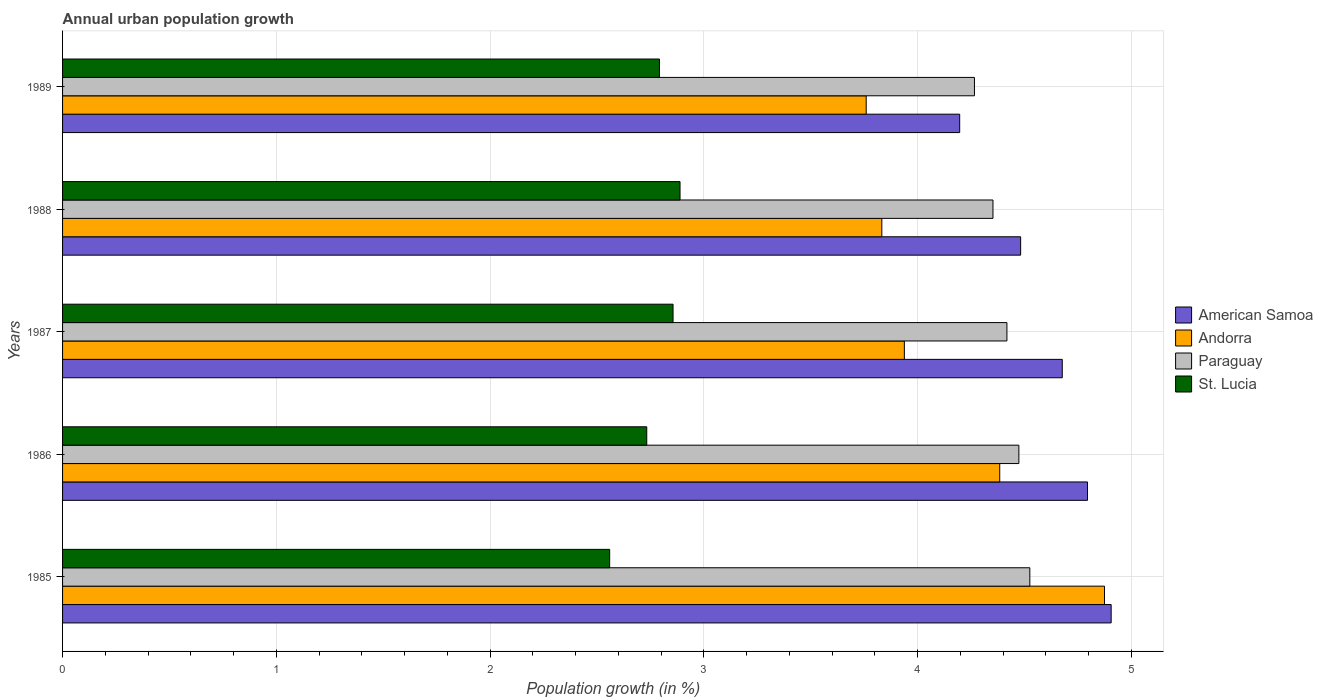Are the number of bars on each tick of the Y-axis equal?
Make the answer very short. Yes. How many bars are there on the 2nd tick from the top?
Give a very brief answer. 4. How many bars are there on the 1st tick from the bottom?
Offer a very short reply. 4. What is the label of the 3rd group of bars from the top?
Provide a succinct answer. 1987. What is the percentage of urban population growth in American Samoa in 1985?
Provide a succinct answer. 4.91. Across all years, what is the maximum percentage of urban population growth in Andorra?
Your answer should be compact. 4.87. Across all years, what is the minimum percentage of urban population growth in American Samoa?
Keep it short and to the point. 4.2. In which year was the percentage of urban population growth in Paraguay maximum?
Your response must be concise. 1985. What is the total percentage of urban population growth in Paraguay in the graph?
Your response must be concise. 22.04. What is the difference between the percentage of urban population growth in American Samoa in 1985 and that in 1987?
Provide a succinct answer. 0.23. What is the difference between the percentage of urban population growth in St. Lucia in 1989 and the percentage of urban population growth in American Samoa in 1986?
Offer a very short reply. -2. What is the average percentage of urban population growth in Andorra per year?
Provide a succinct answer. 4.16. In the year 1988, what is the difference between the percentage of urban population growth in Andorra and percentage of urban population growth in American Samoa?
Your response must be concise. -0.65. In how many years, is the percentage of urban population growth in Andorra greater than 0.6000000000000001 %?
Your answer should be very brief. 5. What is the ratio of the percentage of urban population growth in Andorra in 1986 to that in 1987?
Your answer should be compact. 1.11. Is the percentage of urban population growth in St. Lucia in 1985 less than that in 1989?
Provide a short and direct response. Yes. Is the difference between the percentage of urban population growth in Andorra in 1986 and 1987 greater than the difference between the percentage of urban population growth in American Samoa in 1986 and 1987?
Provide a short and direct response. Yes. What is the difference between the highest and the second highest percentage of urban population growth in St. Lucia?
Your answer should be compact. 0.03. What is the difference between the highest and the lowest percentage of urban population growth in American Samoa?
Ensure brevity in your answer.  0.71. In how many years, is the percentage of urban population growth in American Samoa greater than the average percentage of urban population growth in American Samoa taken over all years?
Ensure brevity in your answer.  3. Is it the case that in every year, the sum of the percentage of urban population growth in Andorra and percentage of urban population growth in Paraguay is greater than the sum of percentage of urban population growth in American Samoa and percentage of urban population growth in St. Lucia?
Provide a succinct answer. No. What does the 4th bar from the top in 1988 represents?
Ensure brevity in your answer.  American Samoa. What does the 2nd bar from the bottom in 1988 represents?
Offer a terse response. Andorra. Is it the case that in every year, the sum of the percentage of urban population growth in St. Lucia and percentage of urban population growth in Paraguay is greater than the percentage of urban population growth in American Samoa?
Your answer should be very brief. Yes. How many bars are there?
Your answer should be compact. 20. What is the difference between two consecutive major ticks on the X-axis?
Provide a short and direct response. 1. Does the graph contain grids?
Ensure brevity in your answer.  Yes. Where does the legend appear in the graph?
Your response must be concise. Center right. How are the legend labels stacked?
Give a very brief answer. Vertical. What is the title of the graph?
Offer a terse response. Annual urban population growth. What is the label or title of the X-axis?
Give a very brief answer. Population growth (in %). What is the label or title of the Y-axis?
Your answer should be compact. Years. What is the Population growth (in %) of American Samoa in 1985?
Make the answer very short. 4.91. What is the Population growth (in %) of Andorra in 1985?
Provide a succinct answer. 4.87. What is the Population growth (in %) in Paraguay in 1985?
Provide a succinct answer. 4.53. What is the Population growth (in %) in St. Lucia in 1985?
Make the answer very short. 2.56. What is the Population growth (in %) of American Samoa in 1986?
Offer a very short reply. 4.79. What is the Population growth (in %) in Andorra in 1986?
Offer a very short reply. 4.38. What is the Population growth (in %) of Paraguay in 1986?
Provide a short and direct response. 4.47. What is the Population growth (in %) of St. Lucia in 1986?
Provide a short and direct response. 2.73. What is the Population growth (in %) in American Samoa in 1987?
Keep it short and to the point. 4.68. What is the Population growth (in %) of Andorra in 1987?
Give a very brief answer. 3.94. What is the Population growth (in %) in Paraguay in 1987?
Your answer should be very brief. 4.42. What is the Population growth (in %) in St. Lucia in 1987?
Provide a short and direct response. 2.86. What is the Population growth (in %) in American Samoa in 1988?
Provide a short and direct response. 4.48. What is the Population growth (in %) of Andorra in 1988?
Keep it short and to the point. 3.83. What is the Population growth (in %) in Paraguay in 1988?
Keep it short and to the point. 4.35. What is the Population growth (in %) of St. Lucia in 1988?
Ensure brevity in your answer.  2.89. What is the Population growth (in %) in American Samoa in 1989?
Your answer should be compact. 4.2. What is the Population growth (in %) of Andorra in 1989?
Your answer should be very brief. 3.76. What is the Population growth (in %) of Paraguay in 1989?
Your answer should be very brief. 4.27. What is the Population growth (in %) in St. Lucia in 1989?
Offer a very short reply. 2.79. Across all years, what is the maximum Population growth (in %) of American Samoa?
Your answer should be compact. 4.91. Across all years, what is the maximum Population growth (in %) of Andorra?
Your response must be concise. 4.87. Across all years, what is the maximum Population growth (in %) in Paraguay?
Provide a succinct answer. 4.53. Across all years, what is the maximum Population growth (in %) in St. Lucia?
Offer a terse response. 2.89. Across all years, what is the minimum Population growth (in %) in American Samoa?
Offer a terse response. 4.2. Across all years, what is the minimum Population growth (in %) in Andorra?
Your response must be concise. 3.76. Across all years, what is the minimum Population growth (in %) of Paraguay?
Give a very brief answer. 4.27. Across all years, what is the minimum Population growth (in %) in St. Lucia?
Offer a very short reply. 2.56. What is the total Population growth (in %) in American Samoa in the graph?
Provide a succinct answer. 23.06. What is the total Population growth (in %) of Andorra in the graph?
Provide a succinct answer. 20.79. What is the total Population growth (in %) in Paraguay in the graph?
Ensure brevity in your answer.  22.04. What is the total Population growth (in %) of St. Lucia in the graph?
Provide a succinct answer. 13.83. What is the difference between the Population growth (in %) in American Samoa in 1985 and that in 1986?
Your response must be concise. 0.11. What is the difference between the Population growth (in %) in Andorra in 1985 and that in 1986?
Your answer should be very brief. 0.49. What is the difference between the Population growth (in %) in Paraguay in 1985 and that in 1986?
Offer a very short reply. 0.05. What is the difference between the Population growth (in %) in St. Lucia in 1985 and that in 1986?
Ensure brevity in your answer.  -0.17. What is the difference between the Population growth (in %) in American Samoa in 1985 and that in 1987?
Your answer should be compact. 0.23. What is the difference between the Population growth (in %) of Andorra in 1985 and that in 1987?
Keep it short and to the point. 0.94. What is the difference between the Population growth (in %) of Paraguay in 1985 and that in 1987?
Provide a short and direct response. 0.11. What is the difference between the Population growth (in %) of St. Lucia in 1985 and that in 1987?
Your answer should be very brief. -0.3. What is the difference between the Population growth (in %) of American Samoa in 1985 and that in 1988?
Offer a terse response. 0.42. What is the difference between the Population growth (in %) in Andorra in 1985 and that in 1988?
Offer a terse response. 1.04. What is the difference between the Population growth (in %) in Paraguay in 1985 and that in 1988?
Your response must be concise. 0.17. What is the difference between the Population growth (in %) in St. Lucia in 1985 and that in 1988?
Keep it short and to the point. -0.33. What is the difference between the Population growth (in %) of American Samoa in 1985 and that in 1989?
Make the answer very short. 0.71. What is the difference between the Population growth (in %) in Andorra in 1985 and that in 1989?
Provide a short and direct response. 1.11. What is the difference between the Population growth (in %) in Paraguay in 1985 and that in 1989?
Offer a terse response. 0.26. What is the difference between the Population growth (in %) in St. Lucia in 1985 and that in 1989?
Your answer should be compact. -0.23. What is the difference between the Population growth (in %) of American Samoa in 1986 and that in 1987?
Provide a succinct answer. 0.12. What is the difference between the Population growth (in %) in Andorra in 1986 and that in 1987?
Keep it short and to the point. 0.45. What is the difference between the Population growth (in %) in Paraguay in 1986 and that in 1987?
Ensure brevity in your answer.  0.06. What is the difference between the Population growth (in %) in St. Lucia in 1986 and that in 1987?
Keep it short and to the point. -0.12. What is the difference between the Population growth (in %) of American Samoa in 1986 and that in 1988?
Offer a terse response. 0.31. What is the difference between the Population growth (in %) in Andorra in 1986 and that in 1988?
Provide a succinct answer. 0.55. What is the difference between the Population growth (in %) of Paraguay in 1986 and that in 1988?
Offer a terse response. 0.12. What is the difference between the Population growth (in %) in St. Lucia in 1986 and that in 1988?
Your answer should be very brief. -0.16. What is the difference between the Population growth (in %) in American Samoa in 1986 and that in 1989?
Your answer should be very brief. 0.6. What is the difference between the Population growth (in %) of Andorra in 1986 and that in 1989?
Offer a very short reply. 0.62. What is the difference between the Population growth (in %) in Paraguay in 1986 and that in 1989?
Your answer should be very brief. 0.21. What is the difference between the Population growth (in %) of St. Lucia in 1986 and that in 1989?
Provide a succinct answer. -0.06. What is the difference between the Population growth (in %) of American Samoa in 1987 and that in 1988?
Offer a very short reply. 0.19. What is the difference between the Population growth (in %) of Andorra in 1987 and that in 1988?
Offer a very short reply. 0.11. What is the difference between the Population growth (in %) in Paraguay in 1987 and that in 1988?
Provide a succinct answer. 0.07. What is the difference between the Population growth (in %) in St. Lucia in 1987 and that in 1988?
Provide a short and direct response. -0.03. What is the difference between the Population growth (in %) in American Samoa in 1987 and that in 1989?
Make the answer very short. 0.48. What is the difference between the Population growth (in %) in Andorra in 1987 and that in 1989?
Offer a very short reply. 0.18. What is the difference between the Population growth (in %) of Paraguay in 1987 and that in 1989?
Your response must be concise. 0.15. What is the difference between the Population growth (in %) of St. Lucia in 1987 and that in 1989?
Offer a terse response. 0.06. What is the difference between the Population growth (in %) in American Samoa in 1988 and that in 1989?
Provide a succinct answer. 0.29. What is the difference between the Population growth (in %) in Andorra in 1988 and that in 1989?
Keep it short and to the point. 0.07. What is the difference between the Population growth (in %) in Paraguay in 1988 and that in 1989?
Keep it short and to the point. 0.09. What is the difference between the Population growth (in %) of St. Lucia in 1988 and that in 1989?
Keep it short and to the point. 0.1. What is the difference between the Population growth (in %) in American Samoa in 1985 and the Population growth (in %) in Andorra in 1986?
Keep it short and to the point. 0.52. What is the difference between the Population growth (in %) of American Samoa in 1985 and the Population growth (in %) of Paraguay in 1986?
Your response must be concise. 0.43. What is the difference between the Population growth (in %) of American Samoa in 1985 and the Population growth (in %) of St. Lucia in 1986?
Ensure brevity in your answer.  2.17. What is the difference between the Population growth (in %) of Andorra in 1985 and the Population growth (in %) of Paraguay in 1986?
Give a very brief answer. 0.4. What is the difference between the Population growth (in %) of Andorra in 1985 and the Population growth (in %) of St. Lucia in 1986?
Give a very brief answer. 2.14. What is the difference between the Population growth (in %) of Paraguay in 1985 and the Population growth (in %) of St. Lucia in 1986?
Provide a short and direct response. 1.79. What is the difference between the Population growth (in %) of American Samoa in 1985 and the Population growth (in %) of Andorra in 1987?
Your answer should be very brief. 0.97. What is the difference between the Population growth (in %) of American Samoa in 1985 and the Population growth (in %) of Paraguay in 1987?
Give a very brief answer. 0.49. What is the difference between the Population growth (in %) of American Samoa in 1985 and the Population growth (in %) of St. Lucia in 1987?
Your answer should be very brief. 2.05. What is the difference between the Population growth (in %) in Andorra in 1985 and the Population growth (in %) in Paraguay in 1987?
Offer a very short reply. 0.46. What is the difference between the Population growth (in %) in Andorra in 1985 and the Population growth (in %) in St. Lucia in 1987?
Give a very brief answer. 2.02. What is the difference between the Population growth (in %) in Paraguay in 1985 and the Population growth (in %) in St. Lucia in 1987?
Provide a short and direct response. 1.67. What is the difference between the Population growth (in %) of American Samoa in 1985 and the Population growth (in %) of Andorra in 1988?
Your answer should be compact. 1.07. What is the difference between the Population growth (in %) in American Samoa in 1985 and the Population growth (in %) in Paraguay in 1988?
Provide a short and direct response. 0.55. What is the difference between the Population growth (in %) of American Samoa in 1985 and the Population growth (in %) of St. Lucia in 1988?
Make the answer very short. 2.02. What is the difference between the Population growth (in %) in Andorra in 1985 and the Population growth (in %) in Paraguay in 1988?
Provide a succinct answer. 0.52. What is the difference between the Population growth (in %) of Andorra in 1985 and the Population growth (in %) of St. Lucia in 1988?
Your answer should be very brief. 1.99. What is the difference between the Population growth (in %) of Paraguay in 1985 and the Population growth (in %) of St. Lucia in 1988?
Ensure brevity in your answer.  1.64. What is the difference between the Population growth (in %) in American Samoa in 1985 and the Population growth (in %) in Andorra in 1989?
Offer a very short reply. 1.15. What is the difference between the Population growth (in %) in American Samoa in 1985 and the Population growth (in %) in Paraguay in 1989?
Provide a short and direct response. 0.64. What is the difference between the Population growth (in %) in American Samoa in 1985 and the Population growth (in %) in St. Lucia in 1989?
Your response must be concise. 2.11. What is the difference between the Population growth (in %) of Andorra in 1985 and the Population growth (in %) of Paraguay in 1989?
Give a very brief answer. 0.61. What is the difference between the Population growth (in %) of Andorra in 1985 and the Population growth (in %) of St. Lucia in 1989?
Your answer should be compact. 2.08. What is the difference between the Population growth (in %) of Paraguay in 1985 and the Population growth (in %) of St. Lucia in 1989?
Your answer should be compact. 1.73. What is the difference between the Population growth (in %) of American Samoa in 1986 and the Population growth (in %) of Andorra in 1987?
Make the answer very short. 0.86. What is the difference between the Population growth (in %) of American Samoa in 1986 and the Population growth (in %) of Paraguay in 1987?
Offer a terse response. 0.38. What is the difference between the Population growth (in %) in American Samoa in 1986 and the Population growth (in %) in St. Lucia in 1987?
Offer a terse response. 1.94. What is the difference between the Population growth (in %) of Andorra in 1986 and the Population growth (in %) of Paraguay in 1987?
Give a very brief answer. -0.03. What is the difference between the Population growth (in %) of Andorra in 1986 and the Population growth (in %) of St. Lucia in 1987?
Your answer should be very brief. 1.53. What is the difference between the Population growth (in %) in Paraguay in 1986 and the Population growth (in %) in St. Lucia in 1987?
Give a very brief answer. 1.62. What is the difference between the Population growth (in %) of American Samoa in 1986 and the Population growth (in %) of Andorra in 1988?
Your response must be concise. 0.96. What is the difference between the Population growth (in %) in American Samoa in 1986 and the Population growth (in %) in Paraguay in 1988?
Give a very brief answer. 0.44. What is the difference between the Population growth (in %) in American Samoa in 1986 and the Population growth (in %) in St. Lucia in 1988?
Provide a succinct answer. 1.91. What is the difference between the Population growth (in %) of Andorra in 1986 and the Population growth (in %) of Paraguay in 1988?
Your response must be concise. 0.03. What is the difference between the Population growth (in %) of Andorra in 1986 and the Population growth (in %) of St. Lucia in 1988?
Make the answer very short. 1.5. What is the difference between the Population growth (in %) of Paraguay in 1986 and the Population growth (in %) of St. Lucia in 1988?
Your answer should be compact. 1.59. What is the difference between the Population growth (in %) of American Samoa in 1986 and the Population growth (in %) of Andorra in 1989?
Provide a short and direct response. 1.04. What is the difference between the Population growth (in %) of American Samoa in 1986 and the Population growth (in %) of Paraguay in 1989?
Provide a succinct answer. 0.53. What is the difference between the Population growth (in %) in American Samoa in 1986 and the Population growth (in %) in St. Lucia in 1989?
Offer a terse response. 2. What is the difference between the Population growth (in %) in Andorra in 1986 and the Population growth (in %) in Paraguay in 1989?
Your answer should be compact. 0.12. What is the difference between the Population growth (in %) of Andorra in 1986 and the Population growth (in %) of St. Lucia in 1989?
Your answer should be very brief. 1.59. What is the difference between the Population growth (in %) in Paraguay in 1986 and the Population growth (in %) in St. Lucia in 1989?
Provide a succinct answer. 1.68. What is the difference between the Population growth (in %) of American Samoa in 1987 and the Population growth (in %) of Andorra in 1988?
Offer a terse response. 0.84. What is the difference between the Population growth (in %) in American Samoa in 1987 and the Population growth (in %) in Paraguay in 1988?
Give a very brief answer. 0.32. What is the difference between the Population growth (in %) of American Samoa in 1987 and the Population growth (in %) of St. Lucia in 1988?
Provide a succinct answer. 1.79. What is the difference between the Population growth (in %) in Andorra in 1987 and the Population growth (in %) in Paraguay in 1988?
Provide a succinct answer. -0.41. What is the difference between the Population growth (in %) in Andorra in 1987 and the Population growth (in %) in St. Lucia in 1988?
Provide a succinct answer. 1.05. What is the difference between the Population growth (in %) in Paraguay in 1987 and the Population growth (in %) in St. Lucia in 1988?
Keep it short and to the point. 1.53. What is the difference between the Population growth (in %) in American Samoa in 1987 and the Population growth (in %) in Andorra in 1989?
Keep it short and to the point. 0.92. What is the difference between the Population growth (in %) in American Samoa in 1987 and the Population growth (in %) in Paraguay in 1989?
Keep it short and to the point. 0.41. What is the difference between the Population growth (in %) in American Samoa in 1987 and the Population growth (in %) in St. Lucia in 1989?
Give a very brief answer. 1.88. What is the difference between the Population growth (in %) of Andorra in 1987 and the Population growth (in %) of Paraguay in 1989?
Offer a terse response. -0.33. What is the difference between the Population growth (in %) in Andorra in 1987 and the Population growth (in %) in St. Lucia in 1989?
Offer a terse response. 1.15. What is the difference between the Population growth (in %) in Paraguay in 1987 and the Population growth (in %) in St. Lucia in 1989?
Give a very brief answer. 1.63. What is the difference between the Population growth (in %) of American Samoa in 1988 and the Population growth (in %) of Andorra in 1989?
Offer a very short reply. 0.72. What is the difference between the Population growth (in %) of American Samoa in 1988 and the Population growth (in %) of Paraguay in 1989?
Your answer should be very brief. 0.22. What is the difference between the Population growth (in %) in American Samoa in 1988 and the Population growth (in %) in St. Lucia in 1989?
Your answer should be very brief. 1.69. What is the difference between the Population growth (in %) in Andorra in 1988 and the Population growth (in %) in Paraguay in 1989?
Give a very brief answer. -0.43. What is the difference between the Population growth (in %) in Andorra in 1988 and the Population growth (in %) in St. Lucia in 1989?
Provide a succinct answer. 1.04. What is the difference between the Population growth (in %) of Paraguay in 1988 and the Population growth (in %) of St. Lucia in 1989?
Your answer should be compact. 1.56. What is the average Population growth (in %) of American Samoa per year?
Make the answer very short. 4.61. What is the average Population growth (in %) of Andorra per year?
Your response must be concise. 4.16. What is the average Population growth (in %) in Paraguay per year?
Provide a short and direct response. 4.41. What is the average Population growth (in %) in St. Lucia per year?
Your response must be concise. 2.77. In the year 1985, what is the difference between the Population growth (in %) in American Samoa and Population growth (in %) in Andorra?
Give a very brief answer. 0.03. In the year 1985, what is the difference between the Population growth (in %) in American Samoa and Population growth (in %) in Paraguay?
Give a very brief answer. 0.38. In the year 1985, what is the difference between the Population growth (in %) in American Samoa and Population growth (in %) in St. Lucia?
Give a very brief answer. 2.35. In the year 1985, what is the difference between the Population growth (in %) in Andorra and Population growth (in %) in Paraguay?
Ensure brevity in your answer.  0.35. In the year 1985, what is the difference between the Population growth (in %) in Andorra and Population growth (in %) in St. Lucia?
Give a very brief answer. 2.31. In the year 1985, what is the difference between the Population growth (in %) of Paraguay and Population growth (in %) of St. Lucia?
Provide a succinct answer. 1.97. In the year 1986, what is the difference between the Population growth (in %) in American Samoa and Population growth (in %) in Andorra?
Make the answer very short. 0.41. In the year 1986, what is the difference between the Population growth (in %) of American Samoa and Population growth (in %) of Paraguay?
Make the answer very short. 0.32. In the year 1986, what is the difference between the Population growth (in %) of American Samoa and Population growth (in %) of St. Lucia?
Provide a succinct answer. 2.06. In the year 1986, what is the difference between the Population growth (in %) in Andorra and Population growth (in %) in Paraguay?
Your answer should be compact. -0.09. In the year 1986, what is the difference between the Population growth (in %) of Andorra and Population growth (in %) of St. Lucia?
Make the answer very short. 1.65. In the year 1986, what is the difference between the Population growth (in %) in Paraguay and Population growth (in %) in St. Lucia?
Offer a terse response. 1.74. In the year 1987, what is the difference between the Population growth (in %) in American Samoa and Population growth (in %) in Andorra?
Keep it short and to the point. 0.74. In the year 1987, what is the difference between the Population growth (in %) in American Samoa and Population growth (in %) in Paraguay?
Offer a very short reply. 0.26. In the year 1987, what is the difference between the Population growth (in %) of American Samoa and Population growth (in %) of St. Lucia?
Your answer should be compact. 1.82. In the year 1987, what is the difference between the Population growth (in %) of Andorra and Population growth (in %) of Paraguay?
Provide a succinct answer. -0.48. In the year 1987, what is the difference between the Population growth (in %) of Andorra and Population growth (in %) of St. Lucia?
Your answer should be compact. 1.08. In the year 1987, what is the difference between the Population growth (in %) in Paraguay and Population growth (in %) in St. Lucia?
Offer a very short reply. 1.56. In the year 1988, what is the difference between the Population growth (in %) of American Samoa and Population growth (in %) of Andorra?
Offer a terse response. 0.65. In the year 1988, what is the difference between the Population growth (in %) of American Samoa and Population growth (in %) of Paraguay?
Offer a terse response. 0.13. In the year 1988, what is the difference between the Population growth (in %) of American Samoa and Population growth (in %) of St. Lucia?
Your response must be concise. 1.59. In the year 1988, what is the difference between the Population growth (in %) of Andorra and Population growth (in %) of Paraguay?
Your answer should be very brief. -0.52. In the year 1988, what is the difference between the Population growth (in %) of Andorra and Population growth (in %) of St. Lucia?
Provide a short and direct response. 0.94. In the year 1988, what is the difference between the Population growth (in %) of Paraguay and Population growth (in %) of St. Lucia?
Ensure brevity in your answer.  1.46. In the year 1989, what is the difference between the Population growth (in %) of American Samoa and Population growth (in %) of Andorra?
Make the answer very short. 0.44. In the year 1989, what is the difference between the Population growth (in %) of American Samoa and Population growth (in %) of Paraguay?
Offer a very short reply. -0.07. In the year 1989, what is the difference between the Population growth (in %) of American Samoa and Population growth (in %) of St. Lucia?
Make the answer very short. 1.4. In the year 1989, what is the difference between the Population growth (in %) in Andorra and Population growth (in %) in Paraguay?
Offer a very short reply. -0.51. In the year 1989, what is the difference between the Population growth (in %) in Andorra and Population growth (in %) in St. Lucia?
Provide a short and direct response. 0.97. In the year 1989, what is the difference between the Population growth (in %) in Paraguay and Population growth (in %) in St. Lucia?
Provide a short and direct response. 1.47. What is the ratio of the Population growth (in %) in American Samoa in 1985 to that in 1986?
Your answer should be compact. 1.02. What is the ratio of the Population growth (in %) of Andorra in 1985 to that in 1986?
Your answer should be very brief. 1.11. What is the ratio of the Population growth (in %) in Paraguay in 1985 to that in 1986?
Provide a short and direct response. 1.01. What is the ratio of the Population growth (in %) of St. Lucia in 1985 to that in 1986?
Keep it short and to the point. 0.94. What is the ratio of the Population growth (in %) of American Samoa in 1985 to that in 1987?
Make the answer very short. 1.05. What is the ratio of the Population growth (in %) in Andorra in 1985 to that in 1987?
Keep it short and to the point. 1.24. What is the ratio of the Population growth (in %) in Paraguay in 1985 to that in 1987?
Your answer should be compact. 1.02. What is the ratio of the Population growth (in %) of St. Lucia in 1985 to that in 1987?
Ensure brevity in your answer.  0.9. What is the ratio of the Population growth (in %) of American Samoa in 1985 to that in 1988?
Your response must be concise. 1.09. What is the ratio of the Population growth (in %) in Andorra in 1985 to that in 1988?
Offer a terse response. 1.27. What is the ratio of the Population growth (in %) in Paraguay in 1985 to that in 1988?
Ensure brevity in your answer.  1.04. What is the ratio of the Population growth (in %) in St. Lucia in 1985 to that in 1988?
Provide a short and direct response. 0.89. What is the ratio of the Population growth (in %) in American Samoa in 1985 to that in 1989?
Provide a succinct answer. 1.17. What is the ratio of the Population growth (in %) of Andorra in 1985 to that in 1989?
Your answer should be very brief. 1.3. What is the ratio of the Population growth (in %) of Paraguay in 1985 to that in 1989?
Your response must be concise. 1.06. What is the ratio of the Population growth (in %) of St. Lucia in 1985 to that in 1989?
Make the answer very short. 0.92. What is the ratio of the Population growth (in %) in American Samoa in 1986 to that in 1987?
Your answer should be very brief. 1.03. What is the ratio of the Population growth (in %) in Andorra in 1986 to that in 1987?
Offer a terse response. 1.11. What is the ratio of the Population growth (in %) of Paraguay in 1986 to that in 1987?
Keep it short and to the point. 1.01. What is the ratio of the Population growth (in %) of St. Lucia in 1986 to that in 1987?
Offer a terse response. 0.96. What is the ratio of the Population growth (in %) of American Samoa in 1986 to that in 1988?
Provide a succinct answer. 1.07. What is the ratio of the Population growth (in %) of Andorra in 1986 to that in 1988?
Your answer should be very brief. 1.14. What is the ratio of the Population growth (in %) of Paraguay in 1986 to that in 1988?
Offer a very short reply. 1.03. What is the ratio of the Population growth (in %) in St. Lucia in 1986 to that in 1988?
Give a very brief answer. 0.95. What is the ratio of the Population growth (in %) of American Samoa in 1986 to that in 1989?
Your response must be concise. 1.14. What is the ratio of the Population growth (in %) of Andorra in 1986 to that in 1989?
Your response must be concise. 1.17. What is the ratio of the Population growth (in %) of Paraguay in 1986 to that in 1989?
Offer a very short reply. 1.05. What is the ratio of the Population growth (in %) of St. Lucia in 1986 to that in 1989?
Offer a very short reply. 0.98. What is the ratio of the Population growth (in %) in American Samoa in 1987 to that in 1988?
Offer a very short reply. 1.04. What is the ratio of the Population growth (in %) in Andorra in 1987 to that in 1988?
Ensure brevity in your answer.  1.03. What is the ratio of the Population growth (in %) of Paraguay in 1987 to that in 1988?
Offer a very short reply. 1.01. What is the ratio of the Population growth (in %) of St. Lucia in 1987 to that in 1988?
Offer a very short reply. 0.99. What is the ratio of the Population growth (in %) of American Samoa in 1987 to that in 1989?
Provide a short and direct response. 1.11. What is the ratio of the Population growth (in %) in Andorra in 1987 to that in 1989?
Give a very brief answer. 1.05. What is the ratio of the Population growth (in %) in Paraguay in 1987 to that in 1989?
Make the answer very short. 1.04. What is the ratio of the Population growth (in %) in St. Lucia in 1987 to that in 1989?
Offer a very short reply. 1.02. What is the ratio of the Population growth (in %) in American Samoa in 1988 to that in 1989?
Make the answer very short. 1.07. What is the ratio of the Population growth (in %) in Andorra in 1988 to that in 1989?
Offer a very short reply. 1.02. What is the ratio of the Population growth (in %) in Paraguay in 1988 to that in 1989?
Provide a succinct answer. 1.02. What is the ratio of the Population growth (in %) in St. Lucia in 1988 to that in 1989?
Your answer should be very brief. 1.03. What is the difference between the highest and the second highest Population growth (in %) of American Samoa?
Make the answer very short. 0.11. What is the difference between the highest and the second highest Population growth (in %) in Andorra?
Your answer should be compact. 0.49. What is the difference between the highest and the second highest Population growth (in %) of Paraguay?
Offer a very short reply. 0.05. What is the difference between the highest and the second highest Population growth (in %) in St. Lucia?
Make the answer very short. 0.03. What is the difference between the highest and the lowest Population growth (in %) in American Samoa?
Keep it short and to the point. 0.71. What is the difference between the highest and the lowest Population growth (in %) of Andorra?
Offer a very short reply. 1.11. What is the difference between the highest and the lowest Population growth (in %) in Paraguay?
Keep it short and to the point. 0.26. What is the difference between the highest and the lowest Population growth (in %) in St. Lucia?
Offer a very short reply. 0.33. 